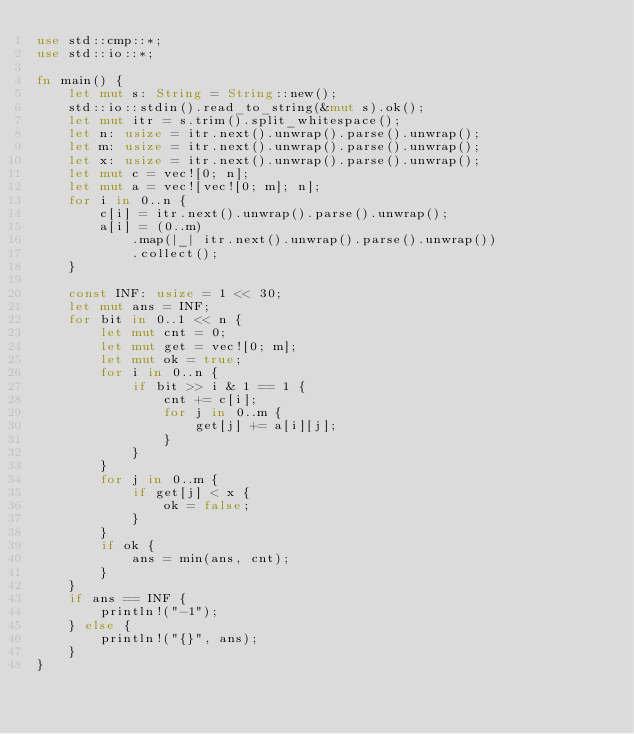<code> <loc_0><loc_0><loc_500><loc_500><_Rust_>use std::cmp::*;
use std::io::*;

fn main() {
    let mut s: String = String::new();
    std::io::stdin().read_to_string(&mut s).ok();
    let mut itr = s.trim().split_whitespace();
    let n: usize = itr.next().unwrap().parse().unwrap();
    let m: usize = itr.next().unwrap().parse().unwrap();
    let x: usize = itr.next().unwrap().parse().unwrap();
    let mut c = vec![0; n];
    let mut a = vec![vec![0; m]; n];
    for i in 0..n {
        c[i] = itr.next().unwrap().parse().unwrap();
        a[i] = (0..m)
            .map(|_| itr.next().unwrap().parse().unwrap())
            .collect();
    }

    const INF: usize = 1 << 30;
    let mut ans = INF;
    for bit in 0..1 << n {
        let mut cnt = 0;
        let mut get = vec![0; m];
        let mut ok = true;
        for i in 0..n {
            if bit >> i & 1 == 1 {
                cnt += c[i];
                for j in 0..m {
                    get[j] += a[i][j];
                }
            }
        }
        for j in 0..m {
            if get[j] < x {
                ok = false;
            }
        }
        if ok {
            ans = min(ans, cnt);
        }
    }
    if ans == INF {
        println!("-1");
    } else {
        println!("{}", ans);
    }
}
</code> 